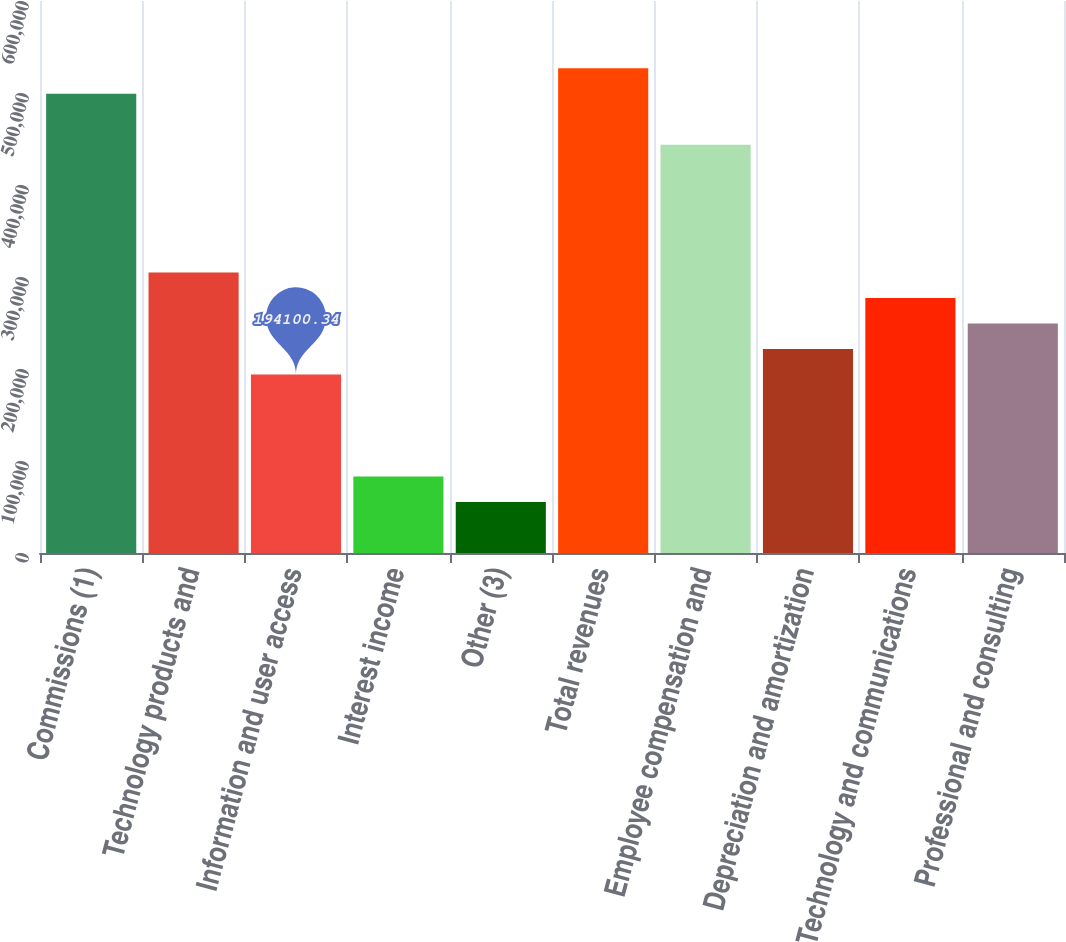Convert chart to OTSL. <chart><loc_0><loc_0><loc_500><loc_500><bar_chart><fcel>Commissions (1)<fcel>Technology products and<fcel>Information and user access<fcel>Interest income<fcel>Other (3)<fcel>Total revenues<fcel>Employee compensation and<fcel>Depreciation and amortization<fcel>Technology and communications<fcel>Professional and consulting<nl><fcel>499114<fcel>305015<fcel>194100<fcel>83186.1<fcel>55457.5<fcel>526843<fcel>443657<fcel>221829<fcel>277286<fcel>249557<nl></chart> 